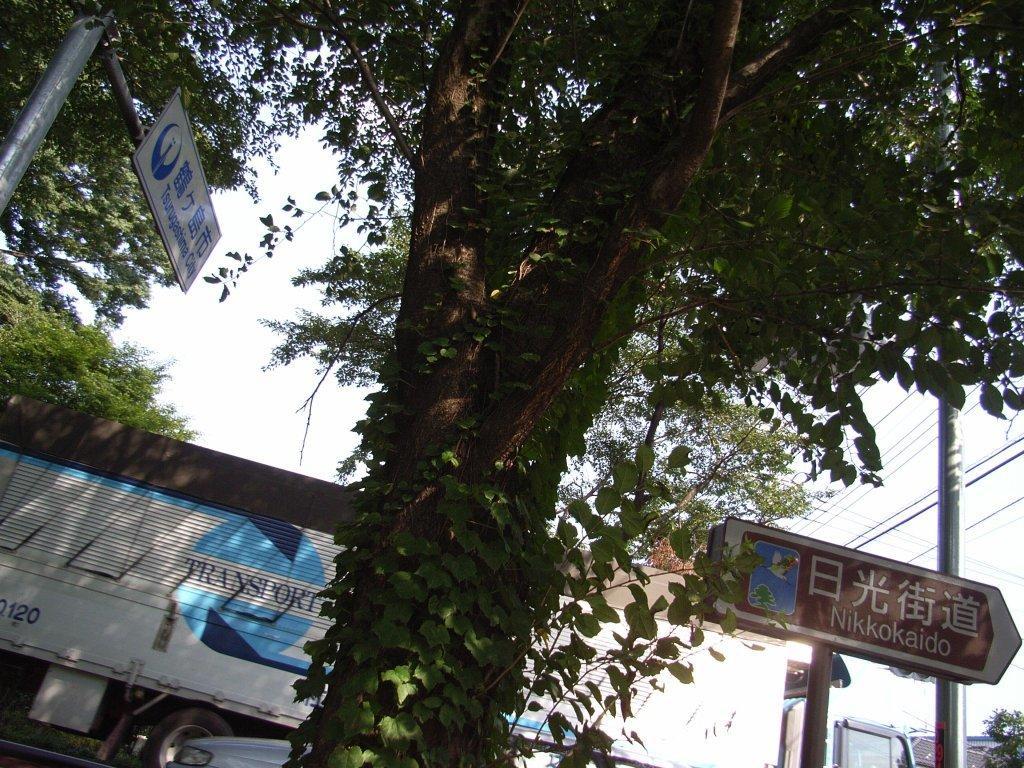In one or two sentences, can you explain what this image depicts? In the picture there is a tall tree and behind the tree there is a vehicle and two direction boards and in the background there is a sky. 